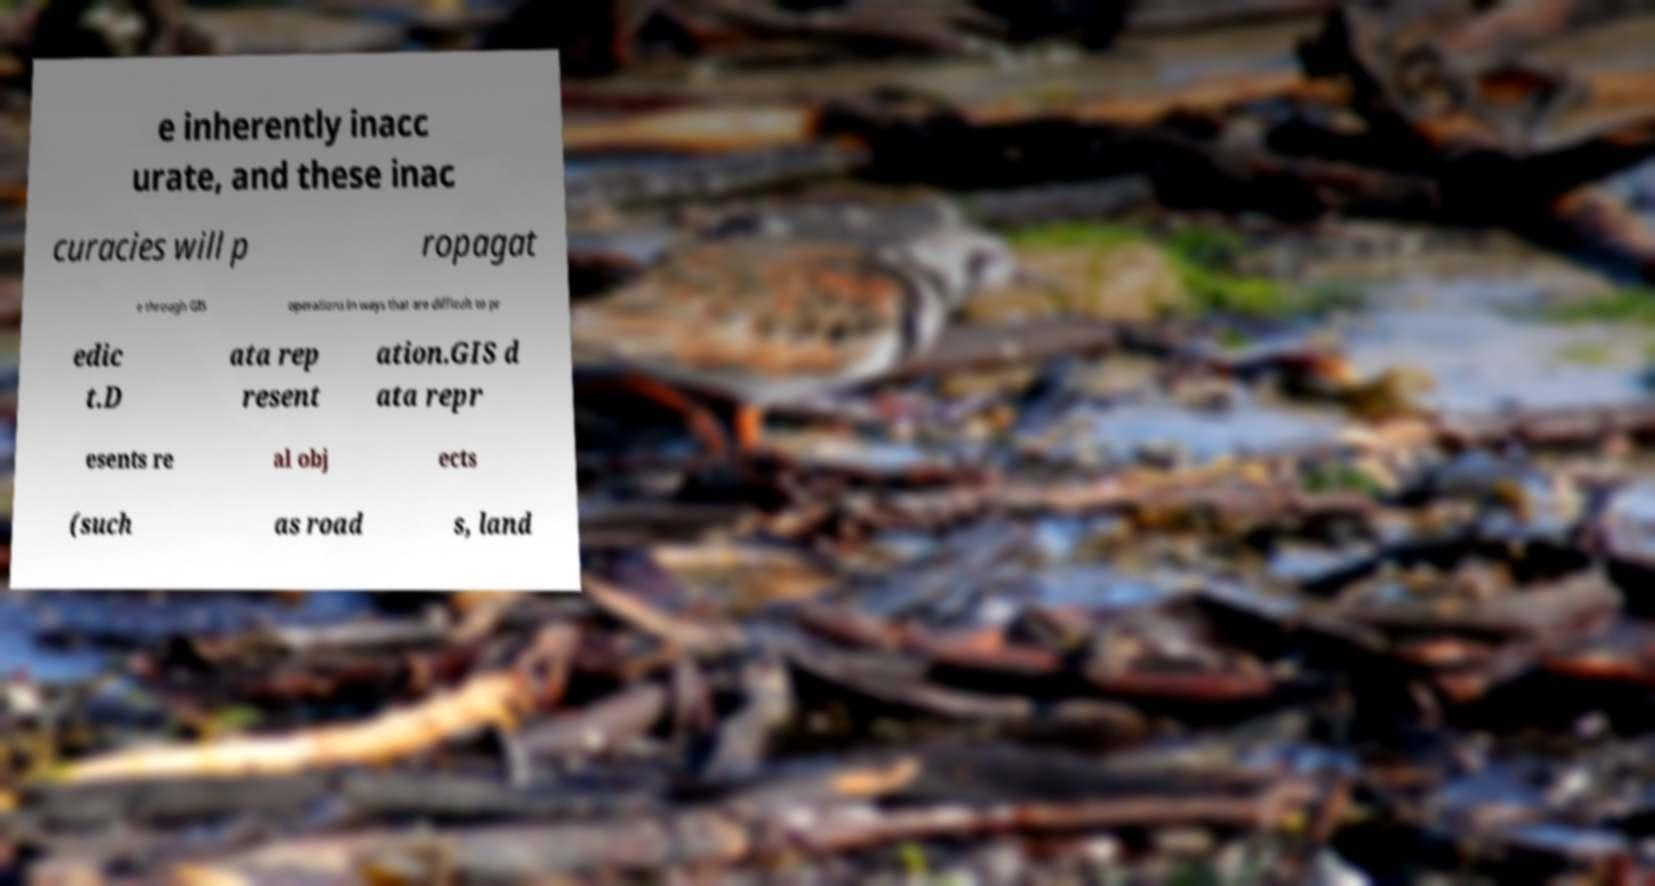Could you extract and type out the text from this image? e inherently inacc urate, and these inac curacies will p ropagat e through GIS operations in ways that are difficult to pr edic t.D ata rep resent ation.GIS d ata repr esents re al obj ects (such as road s, land 